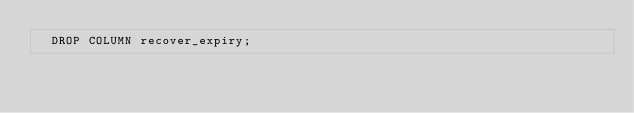<code> <loc_0><loc_0><loc_500><loc_500><_SQL_>  DROP COLUMN recover_expiry;
</code> 